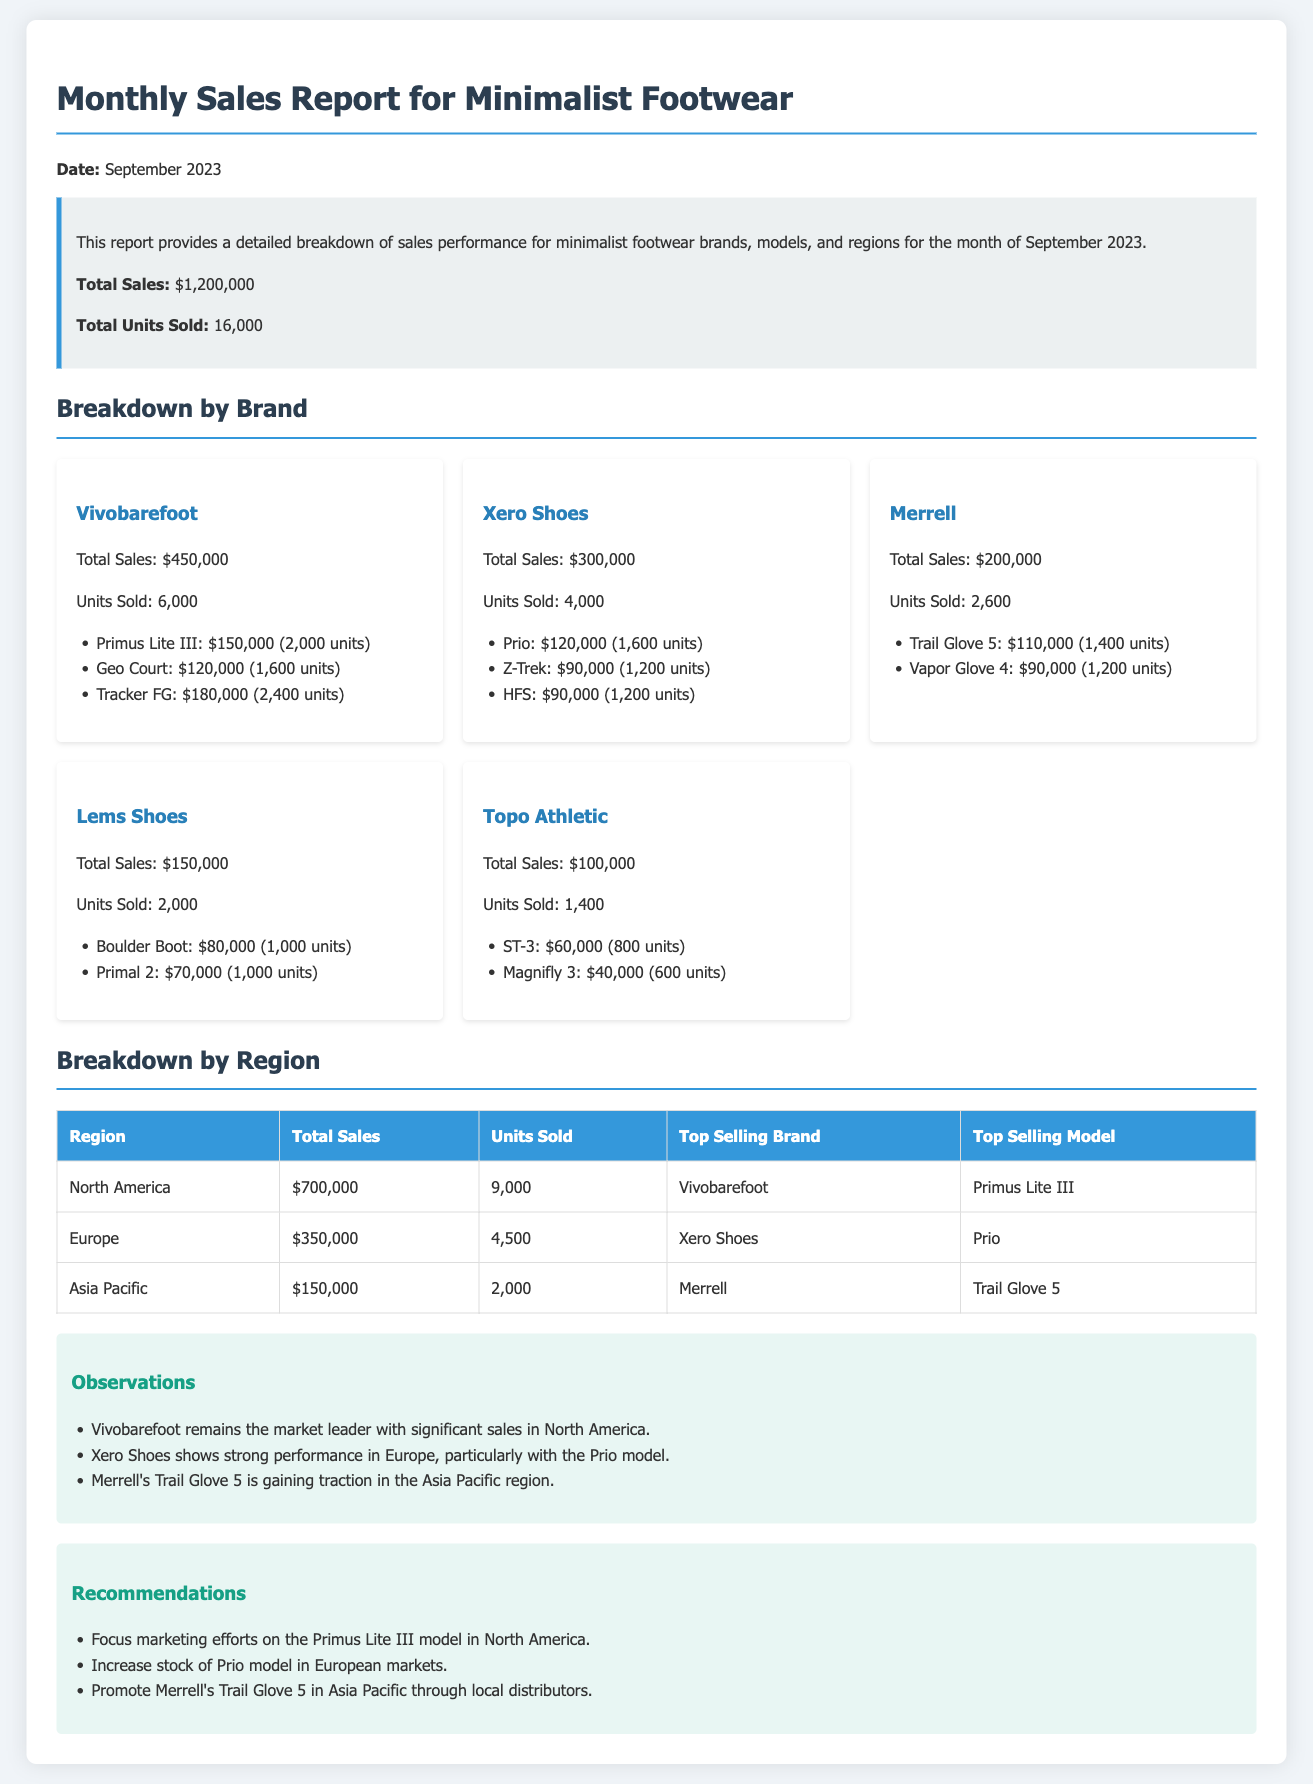what was the total sales for September 2023? The total sales for September 2023 is stated in the summary section of the document.
Answer: $1,200,000 how many units of Vivobarefoot were sold? The number of units sold for Vivobarefoot is explicitly listed in the breakdown by brand section.
Answer: 6,000 which brand had the highest sales? The brand with the highest total sales can be found in the breakdown by brand section.
Answer: Vivobarefoot what was the top-selling model in North America? The top-selling model in North America is mentioned in the breakdown by region table.
Answer: Primus Lite III which region contributed the least to total sales? The region with the lowest total sales can be determined from the breakdown by region table.
Answer: Asia Pacific how many units were sold for the HFS model? The sales data for each model is found in the breakdown by brand section.
Answer: 1,200 units who is the market leader in minimalist footwear? The market leader is identified in the observations section of the document.
Answer: Vivobarefoot what is recommended for Merrell's Trail Glove 5 in the Asia Pacific? The recommendation for Merrell's Trail Glove 5 is stated in the recommendations section.
Answer: Promote through local distributors 